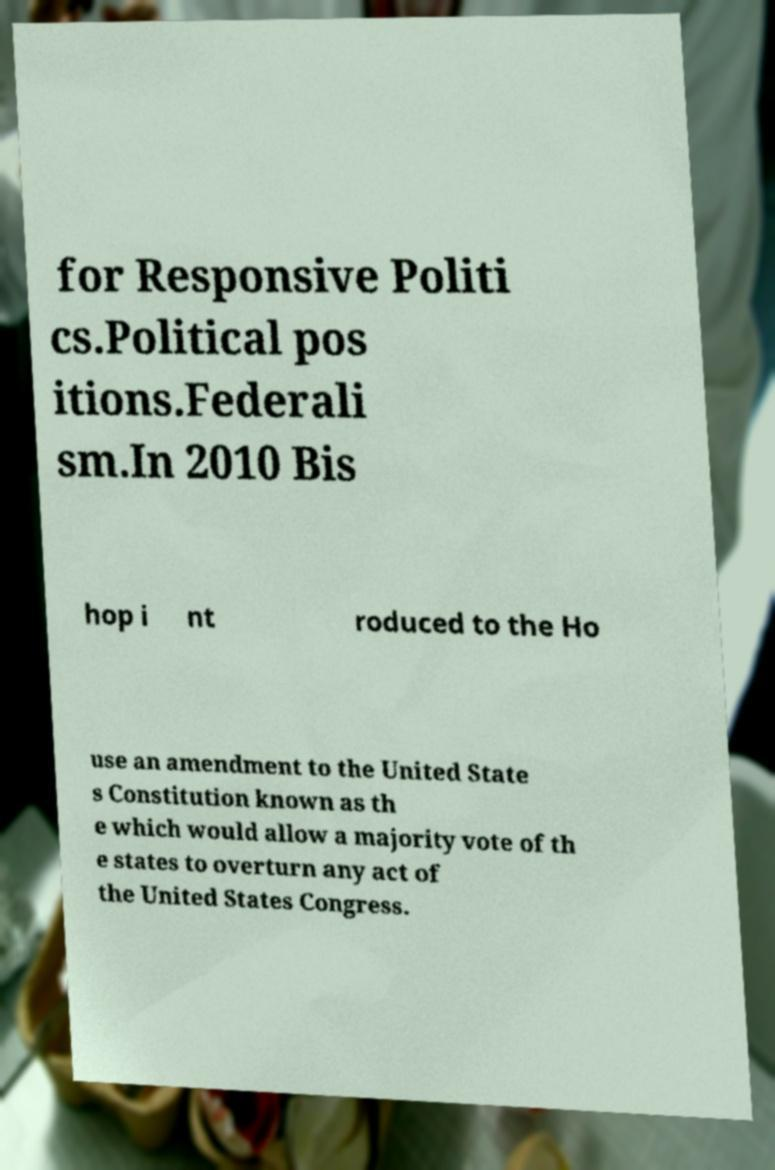Please identify and transcribe the text found in this image. for Responsive Politi cs.Political pos itions.Federali sm.In 2010 Bis hop i nt roduced to the Ho use an amendment to the United State s Constitution known as th e which would allow a majority vote of th e states to overturn any act of the United States Congress. 